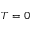Convert formula to latex. <formula><loc_0><loc_0><loc_500><loc_500>T = 0</formula> 